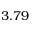<formula> <loc_0><loc_0><loc_500><loc_500>3 . 7 9</formula> 